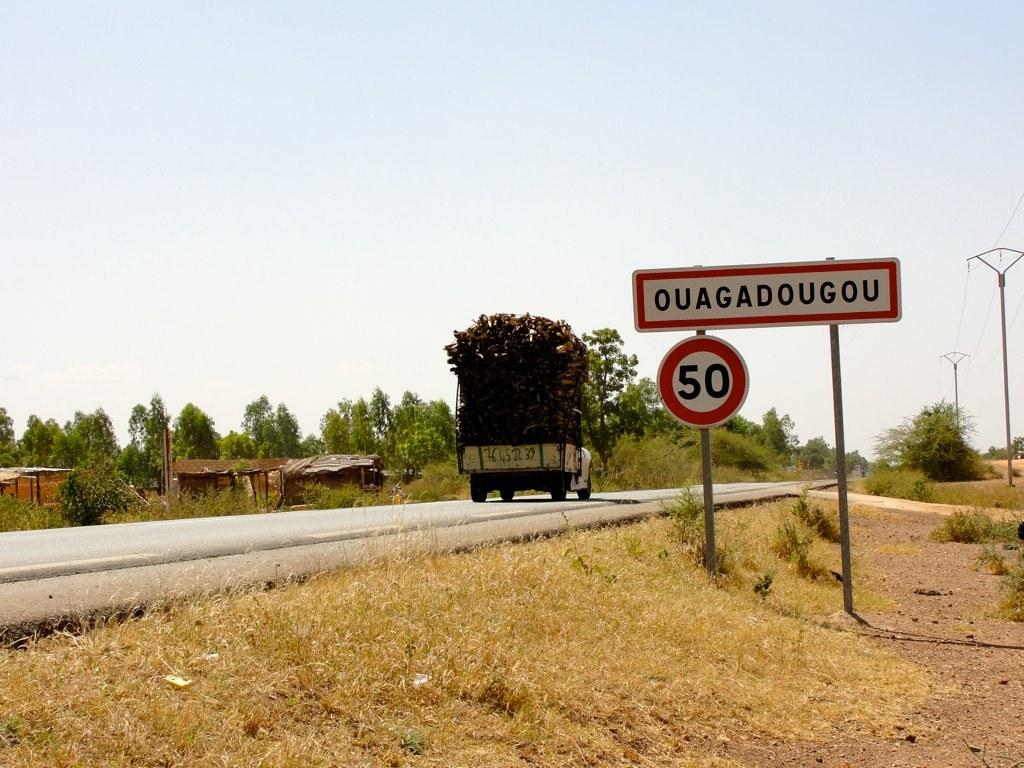<image>
Share a concise interpretation of the image provided. a truck full of logs on a road heading to Ouagadougou 